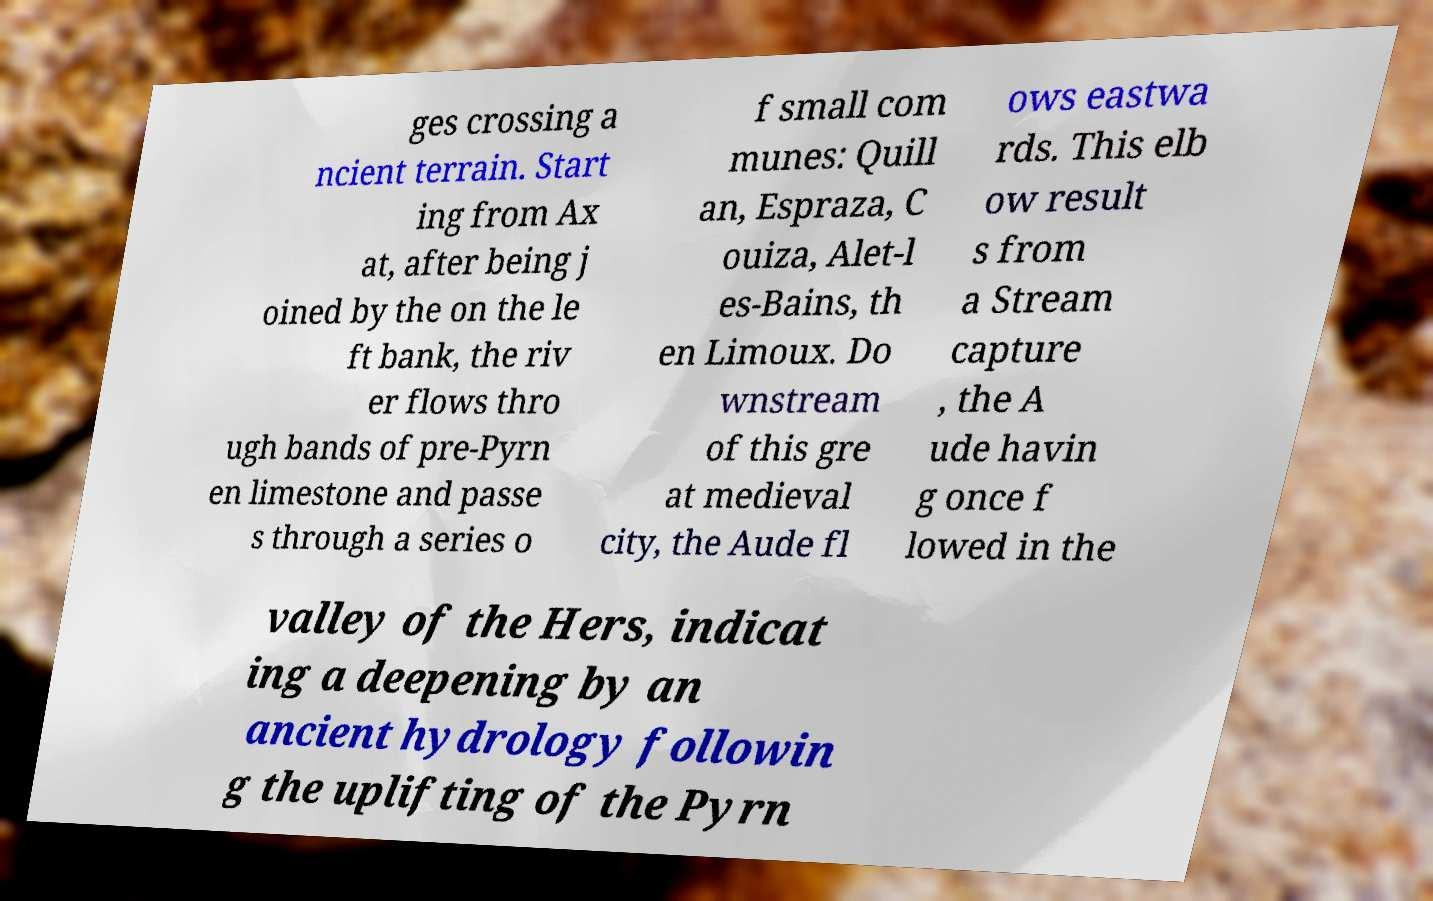For documentation purposes, I need the text within this image transcribed. Could you provide that? ges crossing a ncient terrain. Start ing from Ax at, after being j oined by the on the le ft bank, the riv er flows thro ugh bands of pre-Pyrn en limestone and passe s through a series o f small com munes: Quill an, Espraza, C ouiza, Alet-l es-Bains, th en Limoux. Do wnstream of this gre at medieval city, the Aude fl ows eastwa rds. This elb ow result s from a Stream capture , the A ude havin g once f lowed in the valley of the Hers, indicat ing a deepening by an ancient hydrology followin g the uplifting of the Pyrn 